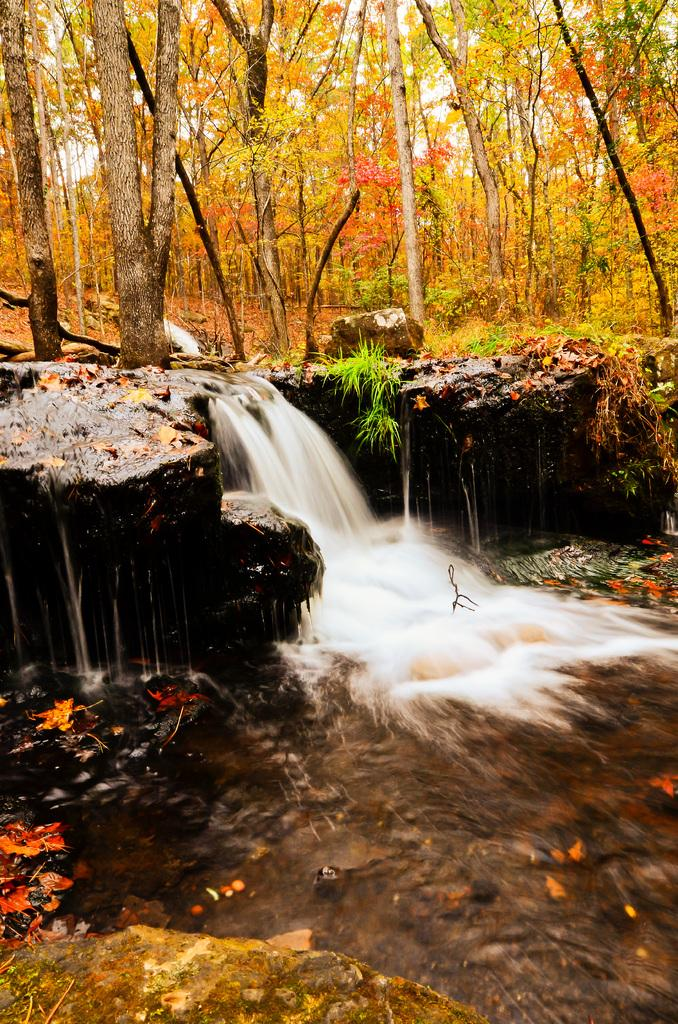What type of natural elements can be seen in the image? There are leaves, rocks, and water visible in the image. What type of vegetation is present in the image? There are trees in the background of the image. What subject is the teacher teaching in the image? There is no teacher or teaching activity present in the image. What type of leaf is the leaf in the image? The provided facts do not specify the type of leaf; it is simply described as "leaves" in the image. 